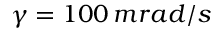Convert formula to latex. <formula><loc_0><loc_0><loc_500><loc_500>\gamma = 1 0 0 \, m r a d / s</formula> 